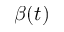<formula> <loc_0><loc_0><loc_500><loc_500>\beta ( t )</formula> 